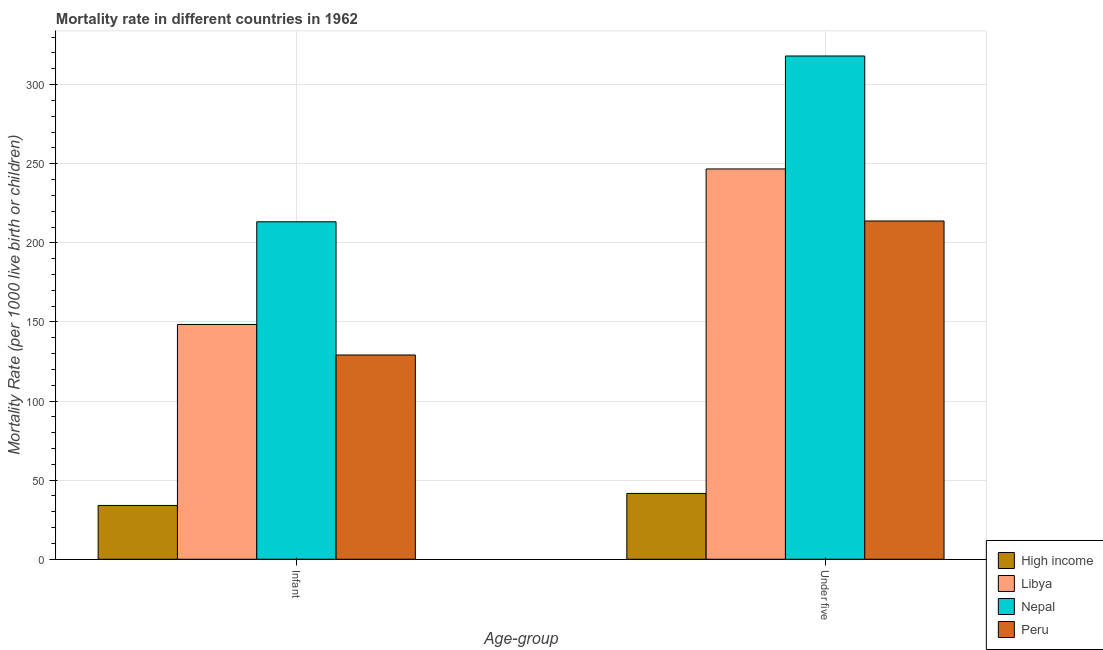Are the number of bars on each tick of the X-axis equal?
Provide a succinct answer. Yes. What is the label of the 1st group of bars from the left?
Offer a very short reply. Infant. What is the infant mortality rate in Peru?
Offer a terse response. 129.1. Across all countries, what is the maximum under-5 mortality rate?
Your answer should be very brief. 318.1. In which country was the infant mortality rate maximum?
Ensure brevity in your answer.  Nepal. In which country was the under-5 mortality rate minimum?
Keep it short and to the point. High income. What is the total under-5 mortality rate in the graph?
Offer a terse response. 820.2. What is the difference between the under-5 mortality rate in Libya and that in High income?
Keep it short and to the point. 205.1. What is the difference between the under-5 mortality rate in High income and the infant mortality rate in Libya?
Provide a succinct answer. -106.8. What is the average under-5 mortality rate per country?
Give a very brief answer. 205.05. What is the difference between the infant mortality rate and under-5 mortality rate in Libya?
Offer a very short reply. -98.3. In how many countries, is the under-5 mortality rate greater than 230 ?
Provide a succinct answer. 2. What is the ratio of the infant mortality rate in Nepal to that in Peru?
Ensure brevity in your answer.  1.65. Is the infant mortality rate in High income less than that in Nepal?
Make the answer very short. Yes. In how many countries, is the infant mortality rate greater than the average infant mortality rate taken over all countries?
Keep it short and to the point. 2. What does the 3rd bar from the right in Infant represents?
Ensure brevity in your answer.  Libya. Are all the bars in the graph horizontal?
Offer a terse response. No. Are the values on the major ticks of Y-axis written in scientific E-notation?
Offer a terse response. No. How many legend labels are there?
Provide a short and direct response. 4. What is the title of the graph?
Ensure brevity in your answer.  Mortality rate in different countries in 1962. Does "Kyrgyz Republic" appear as one of the legend labels in the graph?
Your answer should be very brief. No. What is the label or title of the X-axis?
Your response must be concise. Age-group. What is the label or title of the Y-axis?
Offer a terse response. Mortality Rate (per 1000 live birth or children). What is the Mortality Rate (per 1000 live birth or children) in Libya in Infant?
Your answer should be very brief. 148.4. What is the Mortality Rate (per 1000 live birth or children) of Nepal in Infant?
Offer a very short reply. 213.3. What is the Mortality Rate (per 1000 live birth or children) in Peru in Infant?
Offer a terse response. 129.1. What is the Mortality Rate (per 1000 live birth or children) of High income in Under five?
Ensure brevity in your answer.  41.6. What is the Mortality Rate (per 1000 live birth or children) in Libya in Under five?
Give a very brief answer. 246.7. What is the Mortality Rate (per 1000 live birth or children) of Nepal in Under five?
Give a very brief answer. 318.1. What is the Mortality Rate (per 1000 live birth or children) of Peru in Under five?
Give a very brief answer. 213.8. Across all Age-group, what is the maximum Mortality Rate (per 1000 live birth or children) in High income?
Provide a short and direct response. 41.6. Across all Age-group, what is the maximum Mortality Rate (per 1000 live birth or children) in Libya?
Give a very brief answer. 246.7. Across all Age-group, what is the maximum Mortality Rate (per 1000 live birth or children) in Nepal?
Your answer should be very brief. 318.1. Across all Age-group, what is the maximum Mortality Rate (per 1000 live birth or children) of Peru?
Provide a short and direct response. 213.8. Across all Age-group, what is the minimum Mortality Rate (per 1000 live birth or children) of High income?
Your response must be concise. 34. Across all Age-group, what is the minimum Mortality Rate (per 1000 live birth or children) in Libya?
Offer a terse response. 148.4. Across all Age-group, what is the minimum Mortality Rate (per 1000 live birth or children) of Nepal?
Your response must be concise. 213.3. Across all Age-group, what is the minimum Mortality Rate (per 1000 live birth or children) of Peru?
Your answer should be very brief. 129.1. What is the total Mortality Rate (per 1000 live birth or children) in High income in the graph?
Keep it short and to the point. 75.6. What is the total Mortality Rate (per 1000 live birth or children) of Libya in the graph?
Your answer should be compact. 395.1. What is the total Mortality Rate (per 1000 live birth or children) of Nepal in the graph?
Your answer should be compact. 531.4. What is the total Mortality Rate (per 1000 live birth or children) of Peru in the graph?
Your answer should be compact. 342.9. What is the difference between the Mortality Rate (per 1000 live birth or children) in High income in Infant and that in Under five?
Your answer should be compact. -7.6. What is the difference between the Mortality Rate (per 1000 live birth or children) of Libya in Infant and that in Under five?
Offer a very short reply. -98.3. What is the difference between the Mortality Rate (per 1000 live birth or children) of Nepal in Infant and that in Under five?
Provide a succinct answer. -104.8. What is the difference between the Mortality Rate (per 1000 live birth or children) in Peru in Infant and that in Under five?
Give a very brief answer. -84.7. What is the difference between the Mortality Rate (per 1000 live birth or children) in High income in Infant and the Mortality Rate (per 1000 live birth or children) in Libya in Under five?
Keep it short and to the point. -212.7. What is the difference between the Mortality Rate (per 1000 live birth or children) of High income in Infant and the Mortality Rate (per 1000 live birth or children) of Nepal in Under five?
Make the answer very short. -284.1. What is the difference between the Mortality Rate (per 1000 live birth or children) of High income in Infant and the Mortality Rate (per 1000 live birth or children) of Peru in Under five?
Offer a very short reply. -179.8. What is the difference between the Mortality Rate (per 1000 live birth or children) of Libya in Infant and the Mortality Rate (per 1000 live birth or children) of Nepal in Under five?
Your answer should be compact. -169.7. What is the difference between the Mortality Rate (per 1000 live birth or children) of Libya in Infant and the Mortality Rate (per 1000 live birth or children) of Peru in Under five?
Ensure brevity in your answer.  -65.4. What is the average Mortality Rate (per 1000 live birth or children) of High income per Age-group?
Keep it short and to the point. 37.8. What is the average Mortality Rate (per 1000 live birth or children) of Libya per Age-group?
Keep it short and to the point. 197.55. What is the average Mortality Rate (per 1000 live birth or children) of Nepal per Age-group?
Provide a succinct answer. 265.7. What is the average Mortality Rate (per 1000 live birth or children) of Peru per Age-group?
Provide a succinct answer. 171.45. What is the difference between the Mortality Rate (per 1000 live birth or children) of High income and Mortality Rate (per 1000 live birth or children) of Libya in Infant?
Offer a terse response. -114.4. What is the difference between the Mortality Rate (per 1000 live birth or children) in High income and Mortality Rate (per 1000 live birth or children) in Nepal in Infant?
Provide a succinct answer. -179.3. What is the difference between the Mortality Rate (per 1000 live birth or children) in High income and Mortality Rate (per 1000 live birth or children) in Peru in Infant?
Your response must be concise. -95.1. What is the difference between the Mortality Rate (per 1000 live birth or children) in Libya and Mortality Rate (per 1000 live birth or children) in Nepal in Infant?
Provide a succinct answer. -64.9. What is the difference between the Mortality Rate (per 1000 live birth or children) in Libya and Mortality Rate (per 1000 live birth or children) in Peru in Infant?
Your answer should be compact. 19.3. What is the difference between the Mortality Rate (per 1000 live birth or children) of Nepal and Mortality Rate (per 1000 live birth or children) of Peru in Infant?
Offer a terse response. 84.2. What is the difference between the Mortality Rate (per 1000 live birth or children) of High income and Mortality Rate (per 1000 live birth or children) of Libya in Under five?
Give a very brief answer. -205.1. What is the difference between the Mortality Rate (per 1000 live birth or children) of High income and Mortality Rate (per 1000 live birth or children) of Nepal in Under five?
Your response must be concise. -276.5. What is the difference between the Mortality Rate (per 1000 live birth or children) of High income and Mortality Rate (per 1000 live birth or children) of Peru in Under five?
Your answer should be compact. -172.2. What is the difference between the Mortality Rate (per 1000 live birth or children) in Libya and Mortality Rate (per 1000 live birth or children) in Nepal in Under five?
Give a very brief answer. -71.4. What is the difference between the Mortality Rate (per 1000 live birth or children) in Libya and Mortality Rate (per 1000 live birth or children) in Peru in Under five?
Provide a short and direct response. 32.9. What is the difference between the Mortality Rate (per 1000 live birth or children) of Nepal and Mortality Rate (per 1000 live birth or children) of Peru in Under five?
Your answer should be very brief. 104.3. What is the ratio of the Mortality Rate (per 1000 live birth or children) in High income in Infant to that in Under five?
Keep it short and to the point. 0.82. What is the ratio of the Mortality Rate (per 1000 live birth or children) of Libya in Infant to that in Under five?
Your response must be concise. 0.6. What is the ratio of the Mortality Rate (per 1000 live birth or children) of Nepal in Infant to that in Under five?
Ensure brevity in your answer.  0.67. What is the ratio of the Mortality Rate (per 1000 live birth or children) of Peru in Infant to that in Under five?
Make the answer very short. 0.6. What is the difference between the highest and the second highest Mortality Rate (per 1000 live birth or children) of High income?
Give a very brief answer. 7.6. What is the difference between the highest and the second highest Mortality Rate (per 1000 live birth or children) in Libya?
Ensure brevity in your answer.  98.3. What is the difference between the highest and the second highest Mortality Rate (per 1000 live birth or children) in Nepal?
Provide a short and direct response. 104.8. What is the difference between the highest and the second highest Mortality Rate (per 1000 live birth or children) of Peru?
Offer a very short reply. 84.7. What is the difference between the highest and the lowest Mortality Rate (per 1000 live birth or children) of High income?
Provide a short and direct response. 7.6. What is the difference between the highest and the lowest Mortality Rate (per 1000 live birth or children) in Libya?
Your answer should be very brief. 98.3. What is the difference between the highest and the lowest Mortality Rate (per 1000 live birth or children) in Nepal?
Provide a short and direct response. 104.8. What is the difference between the highest and the lowest Mortality Rate (per 1000 live birth or children) of Peru?
Give a very brief answer. 84.7. 